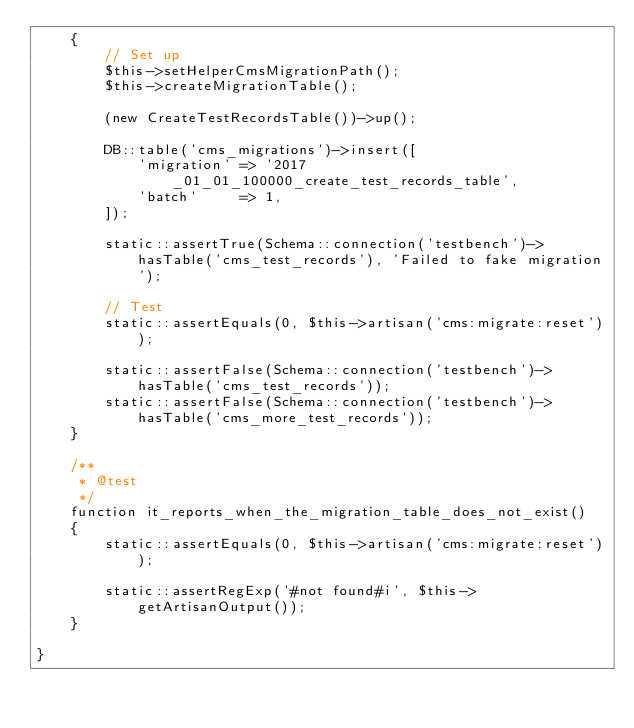Convert code to text. <code><loc_0><loc_0><loc_500><loc_500><_PHP_>    {
        // Set up
        $this->setHelperCmsMigrationPath();
        $this->createMigrationTable();

        (new CreateTestRecordsTable())->up();

        DB::table('cms_migrations')->insert([
            'migration' => '2017_01_01_100000_create_test_records_table',
            'batch'     => 1,
        ]);

        static::assertTrue(Schema::connection('testbench')->hasTable('cms_test_records'), 'Failed to fake migration');

        // Test
        static::assertEquals(0, $this->artisan('cms:migrate:reset'));

        static::assertFalse(Schema::connection('testbench')->hasTable('cms_test_records'));
        static::assertFalse(Schema::connection('testbench')->hasTable('cms_more_test_records'));
    }

    /**
     * @test
     */
    function it_reports_when_the_migration_table_does_not_exist()
    {
        static::assertEquals(0, $this->artisan('cms:migrate:reset'));

        static::assertRegExp('#not found#i', $this->getArtisanOutput());
    }

}
</code> 